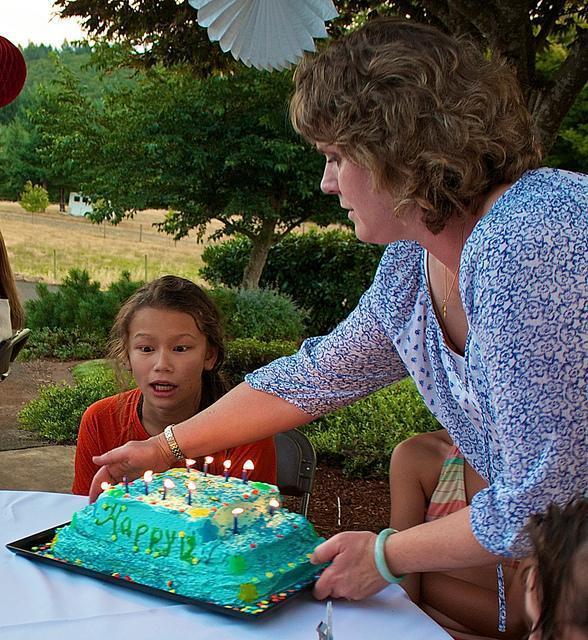How many bracelets is the woman on the right wearing?
Give a very brief answer. 2. How many dining tables are in the photo?
Give a very brief answer. 1. How many people are in the picture?
Give a very brief answer. 5. 